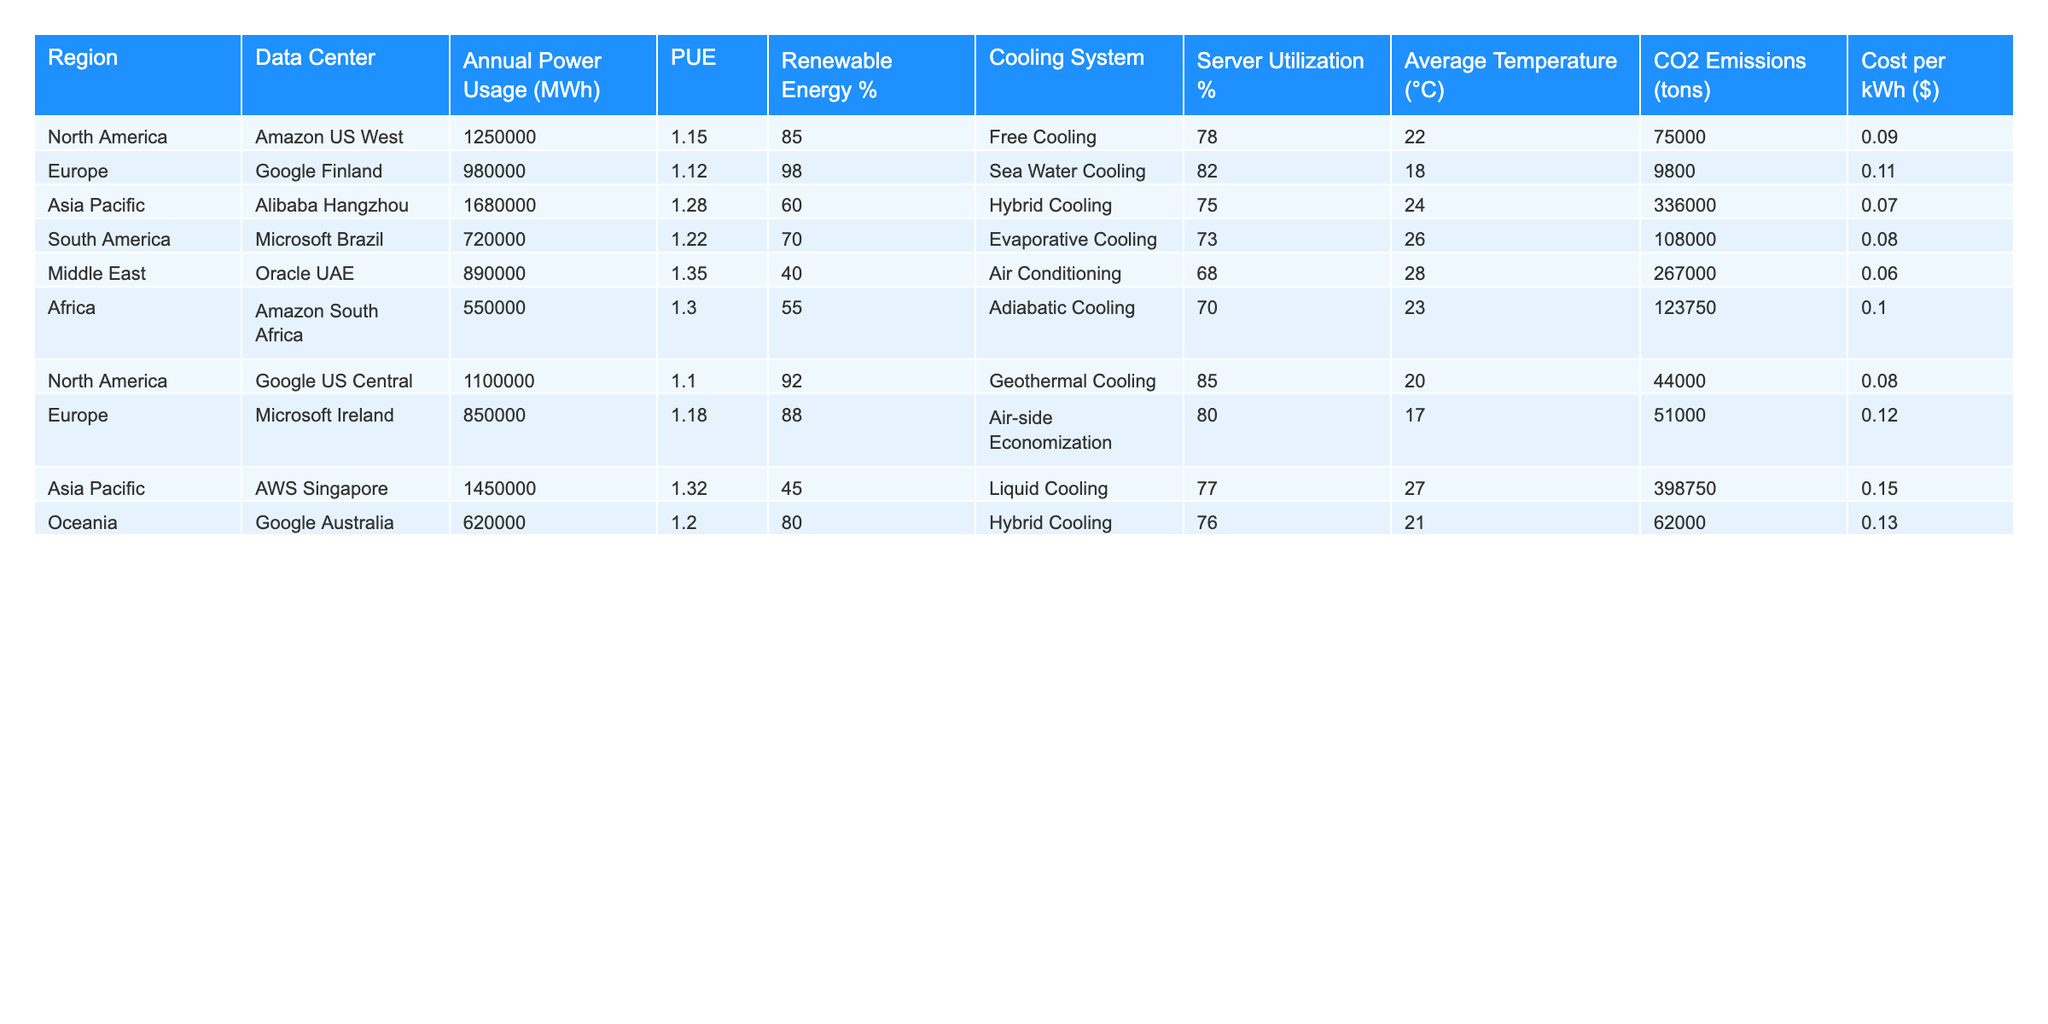What is the annual power usage of the data center located in Europe? From the table, I can see that the data center in Europe is Google Finland, which has an annual power usage of 980,000 MWh.
Answer: 980000 MWh Which data center has the lowest PUE value? Looking through the PUE values in the table, the lowest value is 1.10, which corresponds to the Google US Central data center.
Answer: Google US Central What is the renewable energy percentage of the Oracle UAE data center? The table shows that the renewable energy percentage for the Oracle UAE data center is 40%.
Answer: 40% What is the difference in CO2 emissions between Alibaba Hangzhou and Amazon South Africa data centers? Alibaba Hangzhou emits 336,000 tons of CO2 and Amazon South Africa emits 123,750 tons. The difference is calculated as 336,000 - 123,750 = 212,250 tons.
Answer: 212250 tons Which region has the highest average temperature, and what is that temperature? By comparing the average temperatures, I find that the Middle East has the highest average temperature of 28°C.
Answer: Middle East, 28°C Is the server utilization percentage of the Microsoft Brazil data center above 75%? In the table, the server utilization for Microsoft Brazil is 73%, which is below 75%.
Answer: No What are the total annual power usages of data centers in North America? The annual power usages for North America data centers (Amazon US West and Google US Central) are 1,250,000 MWh and 1,100,000 MWh, respectively. Their total is 1,250,000 + 1,100,000 = 2,350,000 MWh.
Answer: 2350000 MWh What is the average cost per kWh across all data centers? To find the average cost per kWh, sum the costs per kWh: 0.09 + 0.11 + 0.07 + 0.08 + 0.06 + 0.10 + 0.08 + 0.12 + 0.15 + 0.13 = 0.89. Then divide by 10 (the number of data centers): 0.89 / 10 = 0.089.
Answer: 0.089 How many data centers use a cooling system rated over 80% in renewable energy? Examining the table, I see that Google Finland, Google US Central, and Microsoft Ireland are the only data centers with renewable energy percentages above 80%. Therefore, the count is 3.
Answer: 3 Which data center in Asia Pacific has the highest CO2 emissions? Among the data centers listed for the Asia Pacific region, Alibaba Hangzhou has the highest CO2 emissions at 336,000 tons.
Answer: Alibaba Hangzhou, 336000 tons 